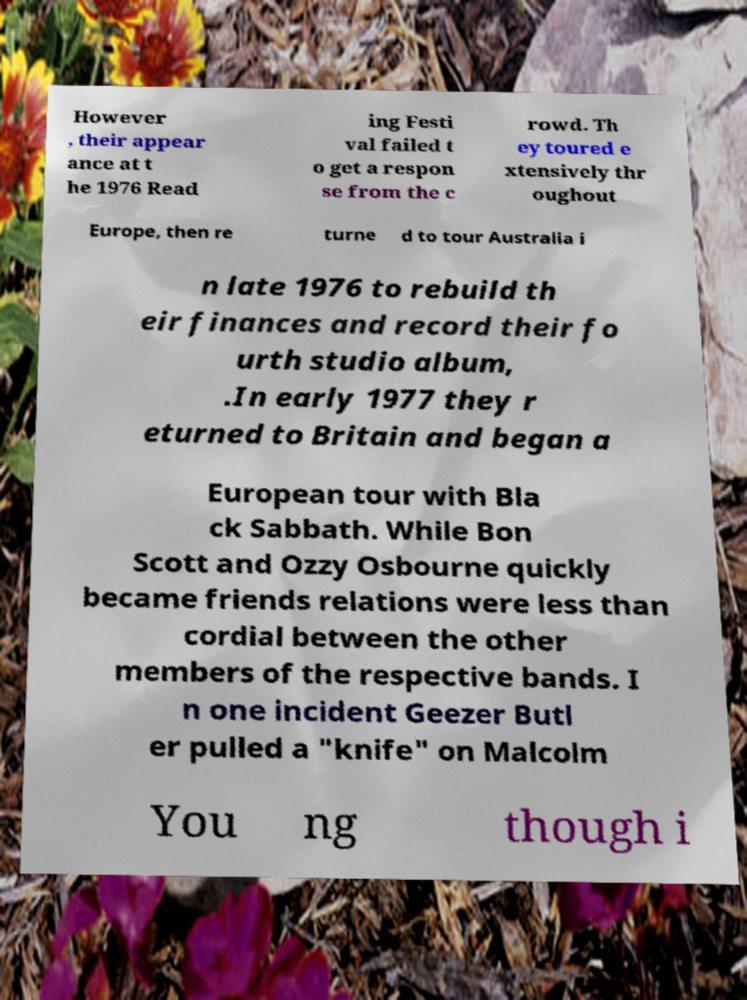I need the written content from this picture converted into text. Can you do that? However , their appear ance at t he 1976 Read ing Festi val failed t o get a respon se from the c rowd. Th ey toured e xtensively thr oughout Europe, then re turne d to tour Australia i n late 1976 to rebuild th eir finances and record their fo urth studio album, .In early 1977 they r eturned to Britain and began a European tour with Bla ck Sabbath. While Bon Scott and Ozzy Osbourne quickly became friends relations were less than cordial between the other members of the respective bands. I n one incident Geezer Butl er pulled a "knife" on Malcolm You ng though i 